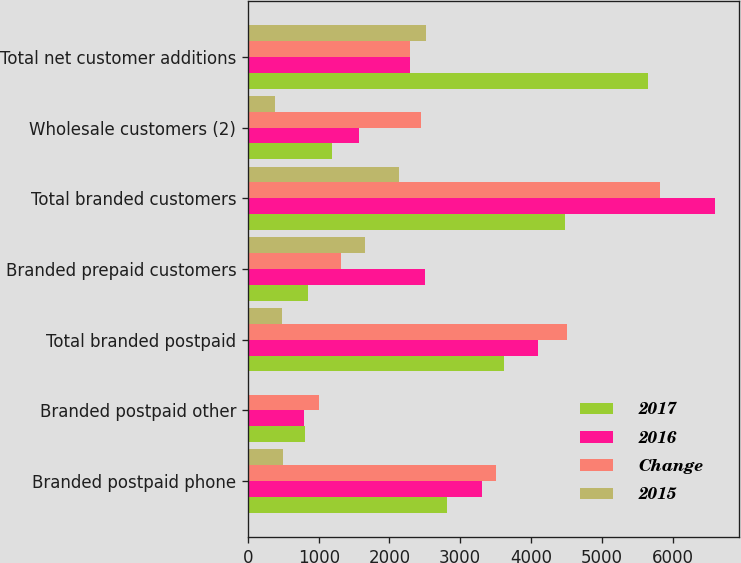Convert chart. <chart><loc_0><loc_0><loc_500><loc_500><stacked_bar_chart><ecel><fcel>Branded postpaid phone<fcel>Branded postpaid other<fcel>Total branded postpaid<fcel>Branded prepaid customers<fcel>Total branded customers<fcel>Wholesale customers (2)<fcel>Total net customer additions<nl><fcel>2017<fcel>2817<fcel>803<fcel>3620<fcel>855<fcel>4475<fcel>1183<fcel>5658<nl><fcel>2016<fcel>3307<fcel>790<fcel>4097<fcel>2508<fcel>6605<fcel>1568<fcel>2284.5<nl><fcel>Change<fcel>3511<fcel>999<fcel>4510<fcel>1315<fcel>5825<fcel>2439<fcel>2284.5<nl><fcel>2015<fcel>490<fcel>13<fcel>477<fcel>1653<fcel>2130<fcel>385<fcel>2515<nl></chart> 